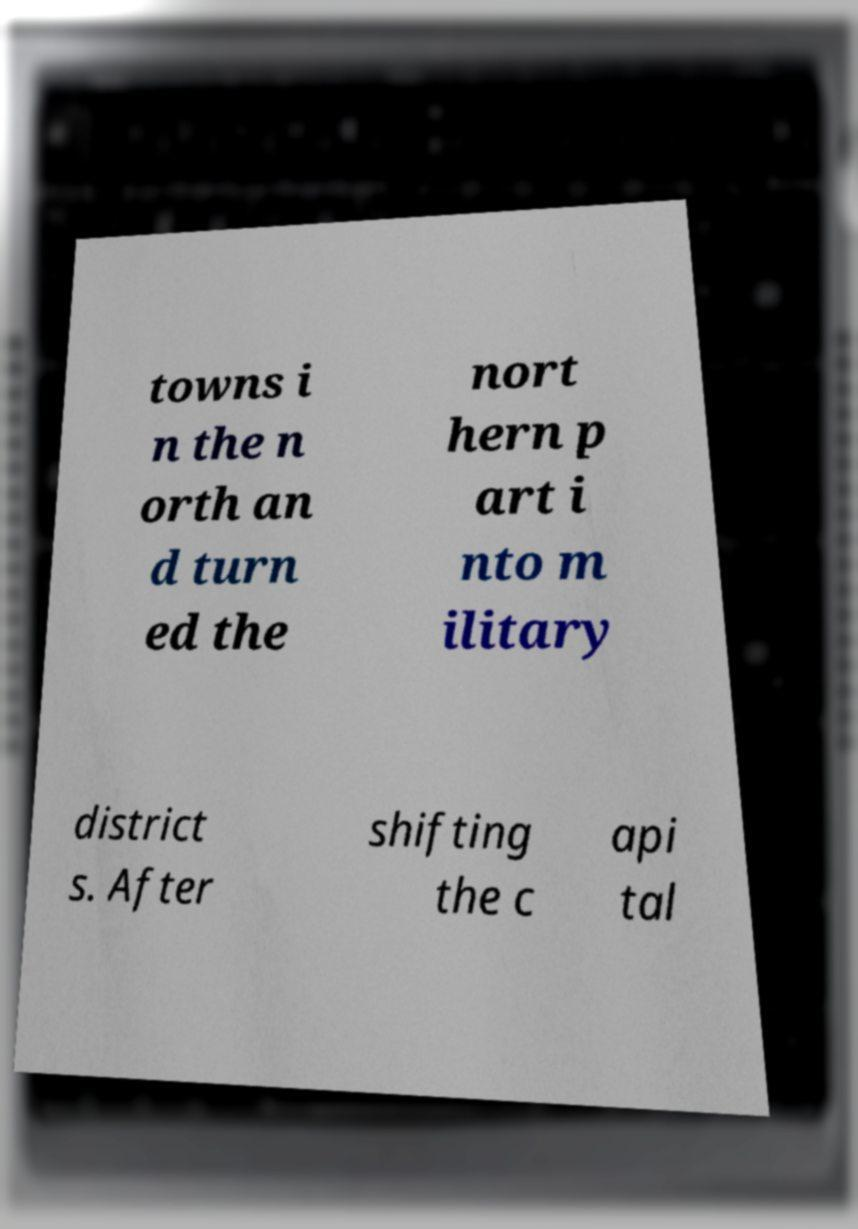Could you extract and type out the text from this image? towns i n the n orth an d turn ed the nort hern p art i nto m ilitary district s. After shifting the c api tal 